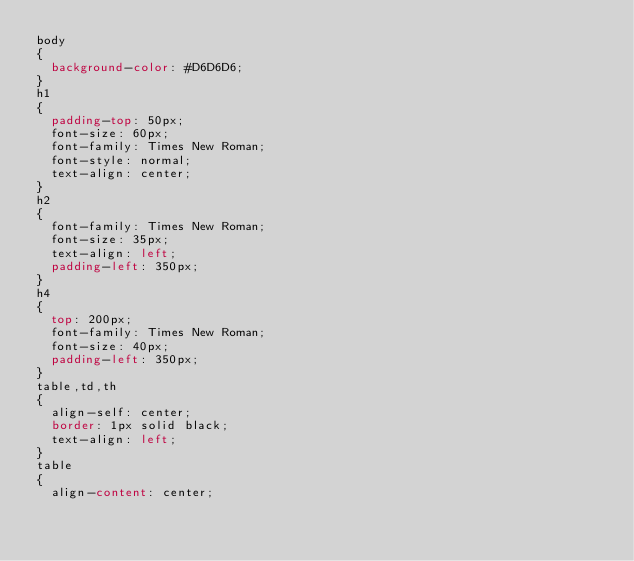Convert code to text. <code><loc_0><loc_0><loc_500><loc_500><_CSS_>body
{
	background-color: #D6D6D6;
}
h1
{
	padding-top: 50px;
	font-size: 60px;
	font-family: Times New Roman;
	font-style: normal;
	text-align: center;
}
h2
{
	font-family: Times New Roman;
	font-size: 35px;
	text-align: left;
	padding-left: 350px;
}
h4
{
	top: 200px;
	font-family: Times New Roman;
	font-size: 40px;
	padding-left: 350px;
}
table,td,th
{
	align-self: center;
	border: 1px solid black;
	text-align: left;
}
table
{
	align-content: center;</code> 